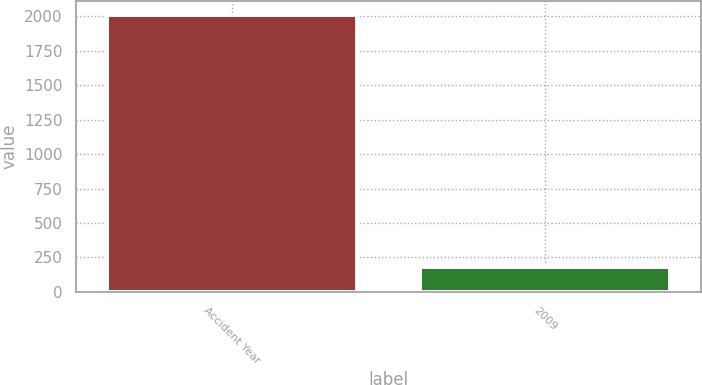Convert chart. <chart><loc_0><loc_0><loc_500><loc_500><bar_chart><fcel>Accident Year<fcel>2009<nl><fcel>2012<fcel>181<nl></chart> 